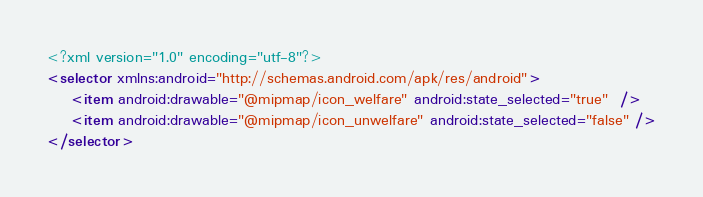<code> <loc_0><loc_0><loc_500><loc_500><_XML_><?xml version="1.0" encoding="utf-8"?>
<selector xmlns:android="http://schemas.android.com/apk/res/android">
    <item android:drawable="@mipmap/icon_welfare" android:state_selected="true"  />
    <item android:drawable="@mipmap/icon_unwelfare" android:state_selected="false" />
</selector></code> 